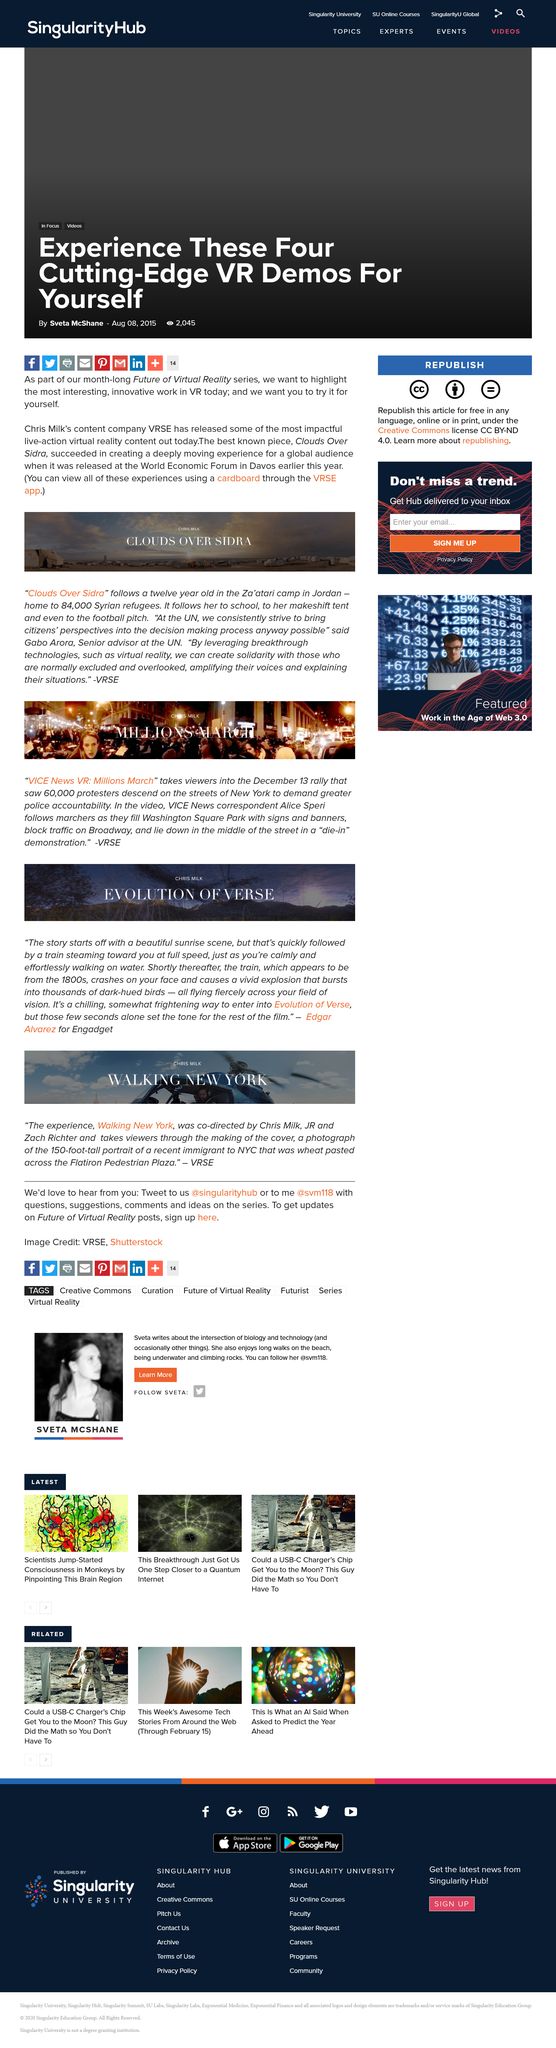List a handful of essential elements in this visual. The story "Evolution Of Verse" starts off with a beautiful sunrise scene. The review of the film was written by Edgar Alvarez for Engadget. Gabo Arora is a senior advisor at the United Nations. As of the current count, approximately 84,000 Syrian refugees are currently residing in the Za'atari refugee camp. The Za’atari camp is located in Jordan. 